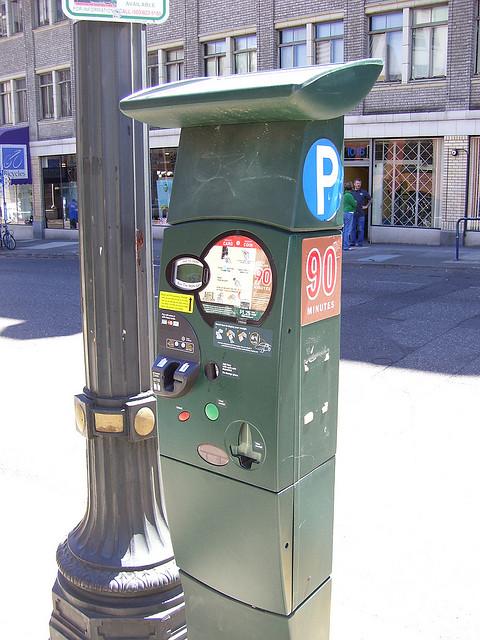What color is the large black pole to the left of the machine?
Concise answer only. Black. Is this parking meter from the 1920s?
Quick response, please. No. Is this a telephone booth?
Be succinct. No. 